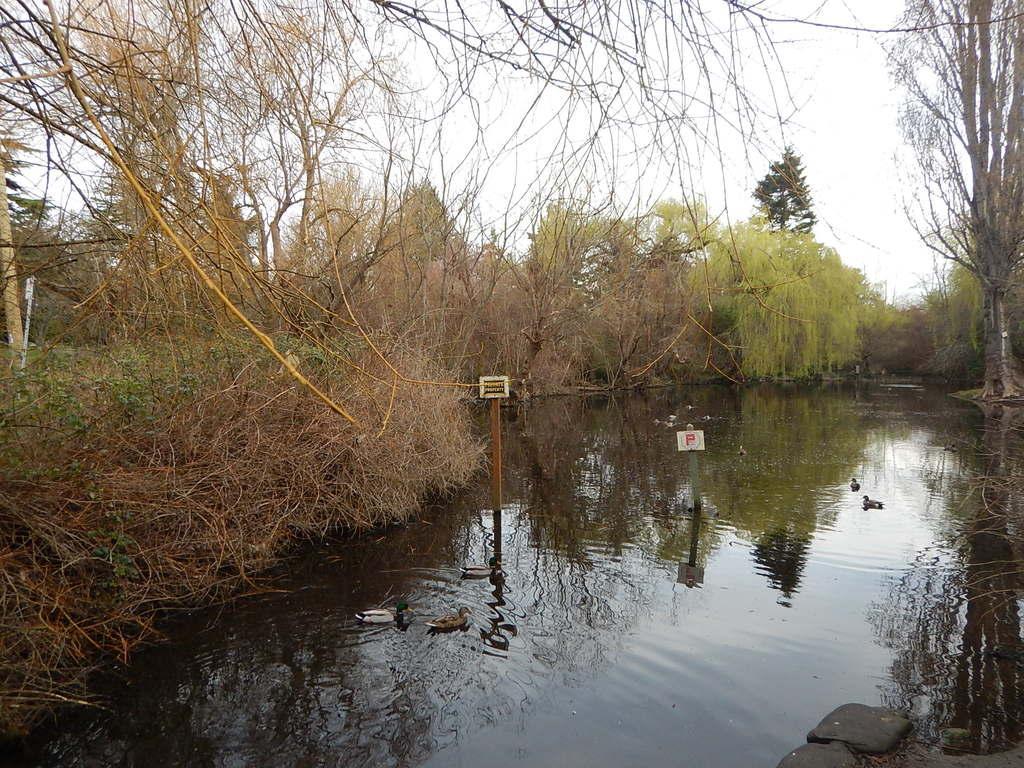How would you summarize this image in a sentence or two? In this image we can see water, birds, poles, boards, plants, and trees. In the background there is sky. 